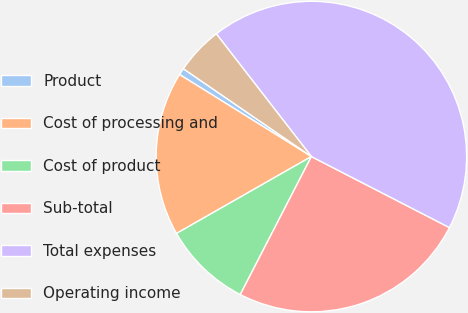Convert chart to OTSL. <chart><loc_0><loc_0><loc_500><loc_500><pie_chart><fcel>Product<fcel>Cost of processing and<fcel>Cost of product<fcel>Sub-total<fcel>Total expenses<fcel>Operating income<nl><fcel>0.71%<fcel>17.11%<fcel>9.18%<fcel>25.01%<fcel>43.06%<fcel>4.94%<nl></chart> 